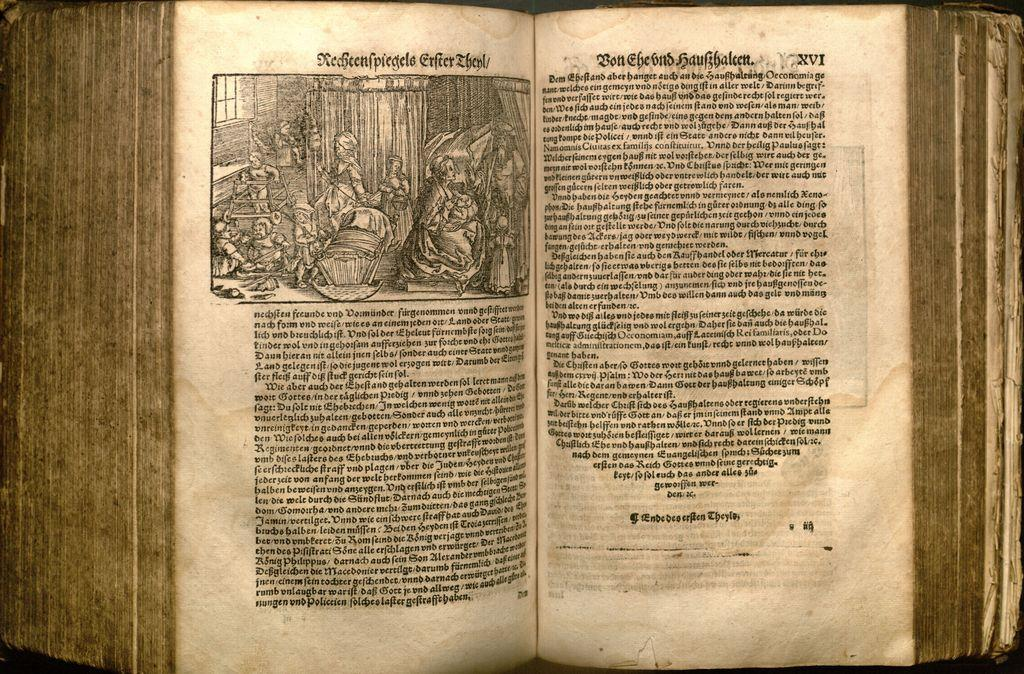<image>
Present a compact description of the photo's key features. an old book in German text including the word Ende 